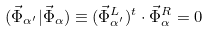<formula> <loc_0><loc_0><loc_500><loc_500>( { \vec { \Phi } } _ { \alpha ^ { \prime } } | { \vec { \Phi } } _ { \alpha } ) \equiv ( { \vec { \Phi } } _ { \alpha ^ { \prime } } ^ { L } ) ^ { t } \cdot { \vec { \Phi } } _ { \alpha } ^ { R } = 0</formula> 